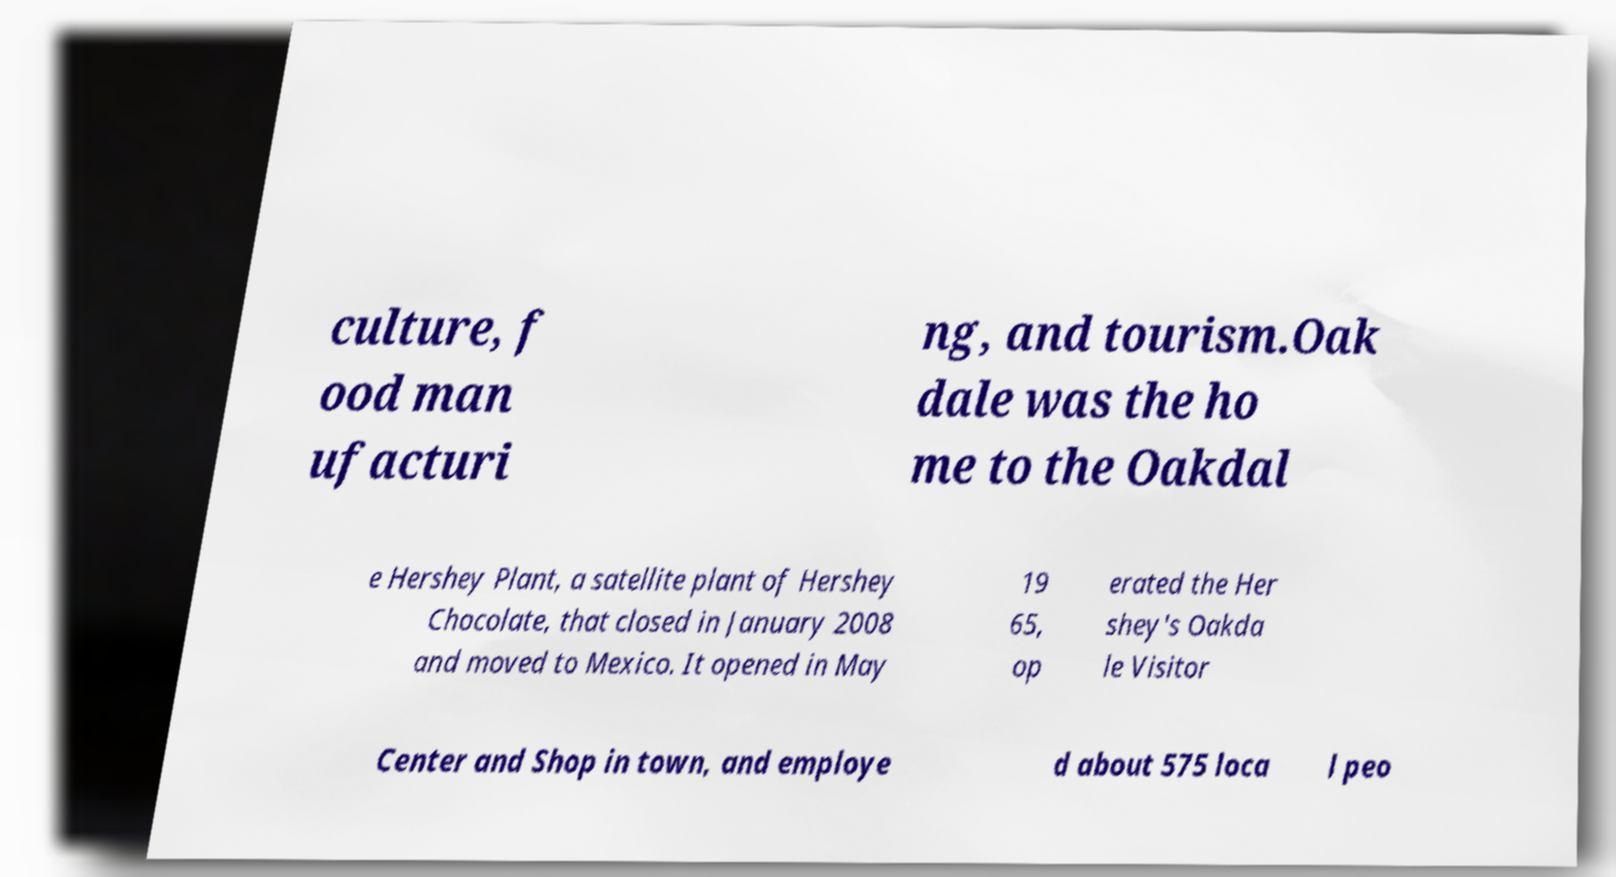There's text embedded in this image that I need extracted. Can you transcribe it verbatim? culture, f ood man ufacturi ng, and tourism.Oak dale was the ho me to the Oakdal e Hershey Plant, a satellite plant of Hershey Chocolate, that closed in January 2008 and moved to Mexico. It opened in May 19 65, op erated the Her shey's Oakda le Visitor Center and Shop in town, and employe d about 575 loca l peo 